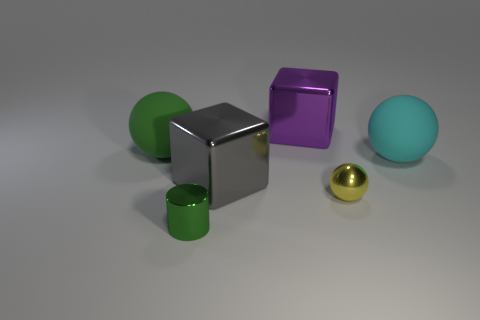There is another big object that is the same shape as the large gray metal thing; what color is it?
Give a very brief answer. Purple. Are there any other things that are the same shape as the tiny green thing?
Your response must be concise. No. There is a tiny ball that is the same material as the green cylinder; what color is it?
Ensure brevity in your answer.  Yellow. There is a large block on the left side of the metallic object that is behind the big green sphere; is there a big metal block that is behind it?
Provide a short and direct response. Yes. Are there fewer large purple things that are left of the purple thing than things that are in front of the large gray metallic block?
Ensure brevity in your answer.  Yes. How many cyan balls are the same material as the tiny green object?
Give a very brief answer. 0. Do the green metallic object and the green thing that is behind the cylinder have the same size?
Keep it short and to the point. No. What is the size of the rubber ball that is right of the small thing that is right of the object that is in front of the tiny yellow metal thing?
Offer a very short reply. Large. Is the number of big matte things on the right side of the large green rubber object greater than the number of large cubes that are right of the purple metal object?
Your answer should be very brief. Yes. What number of gray metallic objects are in front of the large rubber ball left of the small metallic sphere?
Ensure brevity in your answer.  1. 